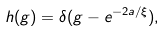<formula> <loc_0><loc_0><loc_500><loc_500>h ( g ) = \delta ( g - e ^ { - 2 a / \xi } ) ,</formula> 